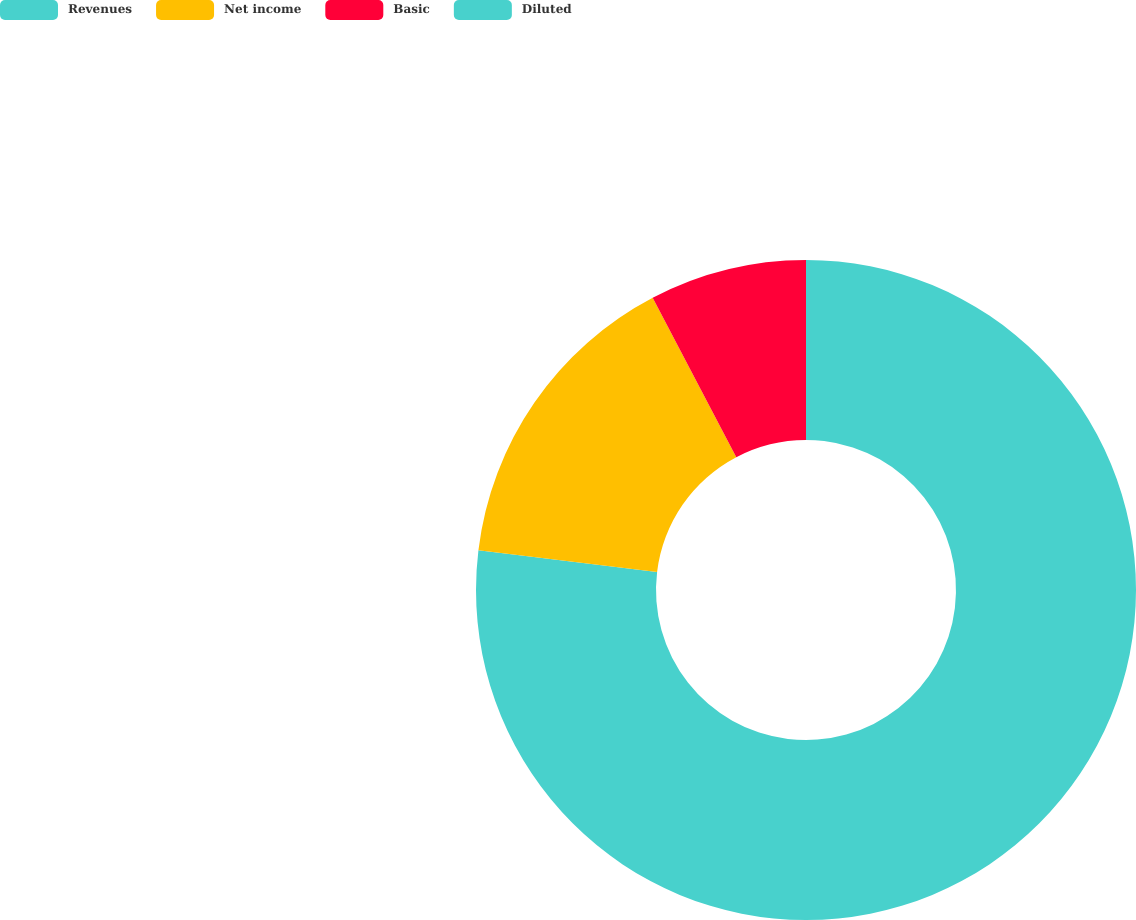<chart> <loc_0><loc_0><loc_500><loc_500><pie_chart><fcel>Revenues<fcel>Net income<fcel>Basic<fcel>Diluted<nl><fcel>76.92%<fcel>15.38%<fcel>7.69%<fcel>0.0%<nl></chart> 